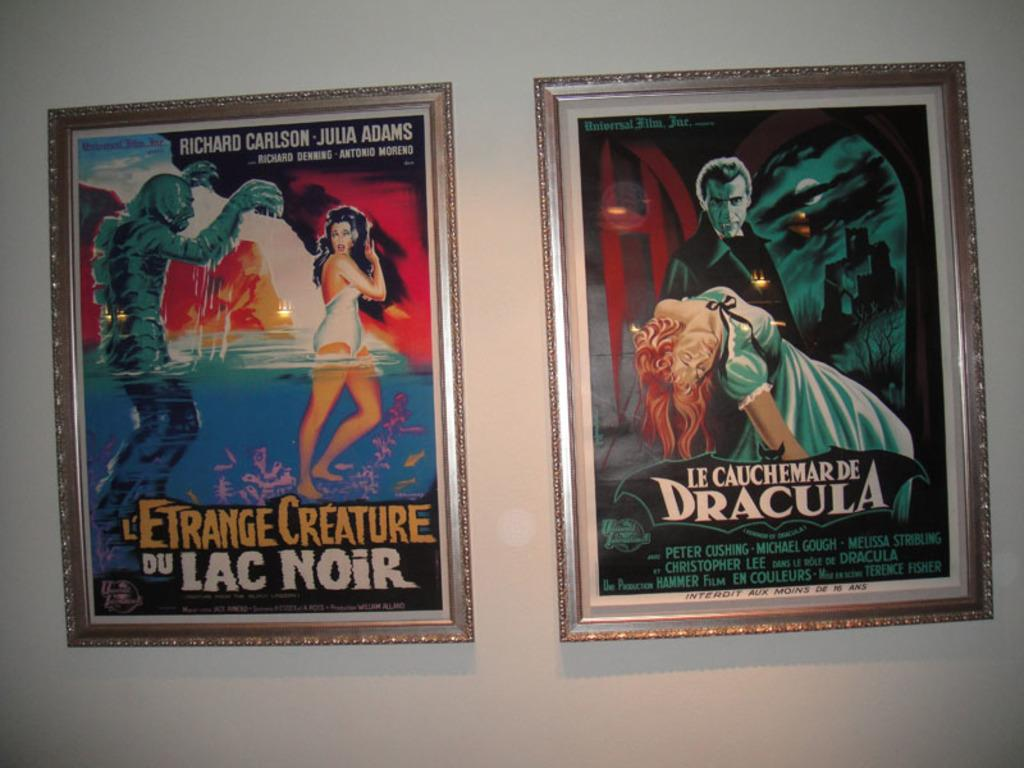<image>
Share a concise interpretation of the image provided. L'Etrange Creature Du Lac Noir stars Richard Carlson and Julia Adams. 